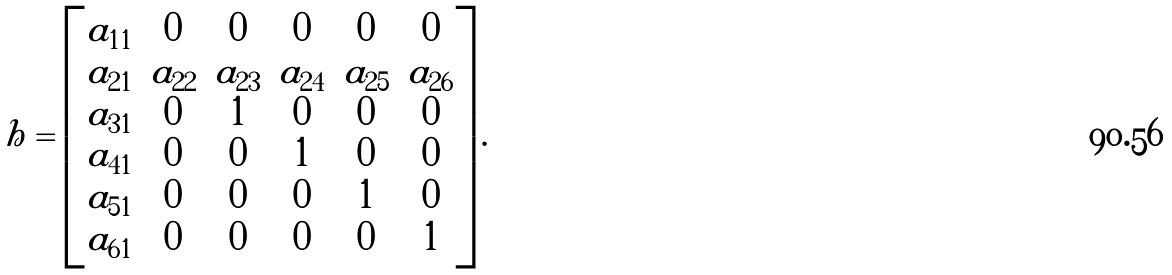<formula> <loc_0><loc_0><loc_500><loc_500>h = \begin{bmatrix} a _ { 1 1 } & 0 & 0 & 0 & 0 & 0 \\ a _ { 2 1 } & a _ { 2 2 } & a _ { 2 3 } & a _ { 2 4 } & a _ { 2 5 } & a _ { 2 6 } \\ a _ { 3 1 } & 0 & 1 & 0 & 0 & 0 \\ a _ { 4 1 } & 0 & 0 & 1 & 0 & 0 \\ a _ { 5 1 } & 0 & 0 & 0 & 1 & 0 \\ a _ { 6 1 } & 0 & 0 & 0 & 0 & 1 \end{bmatrix} .</formula> 